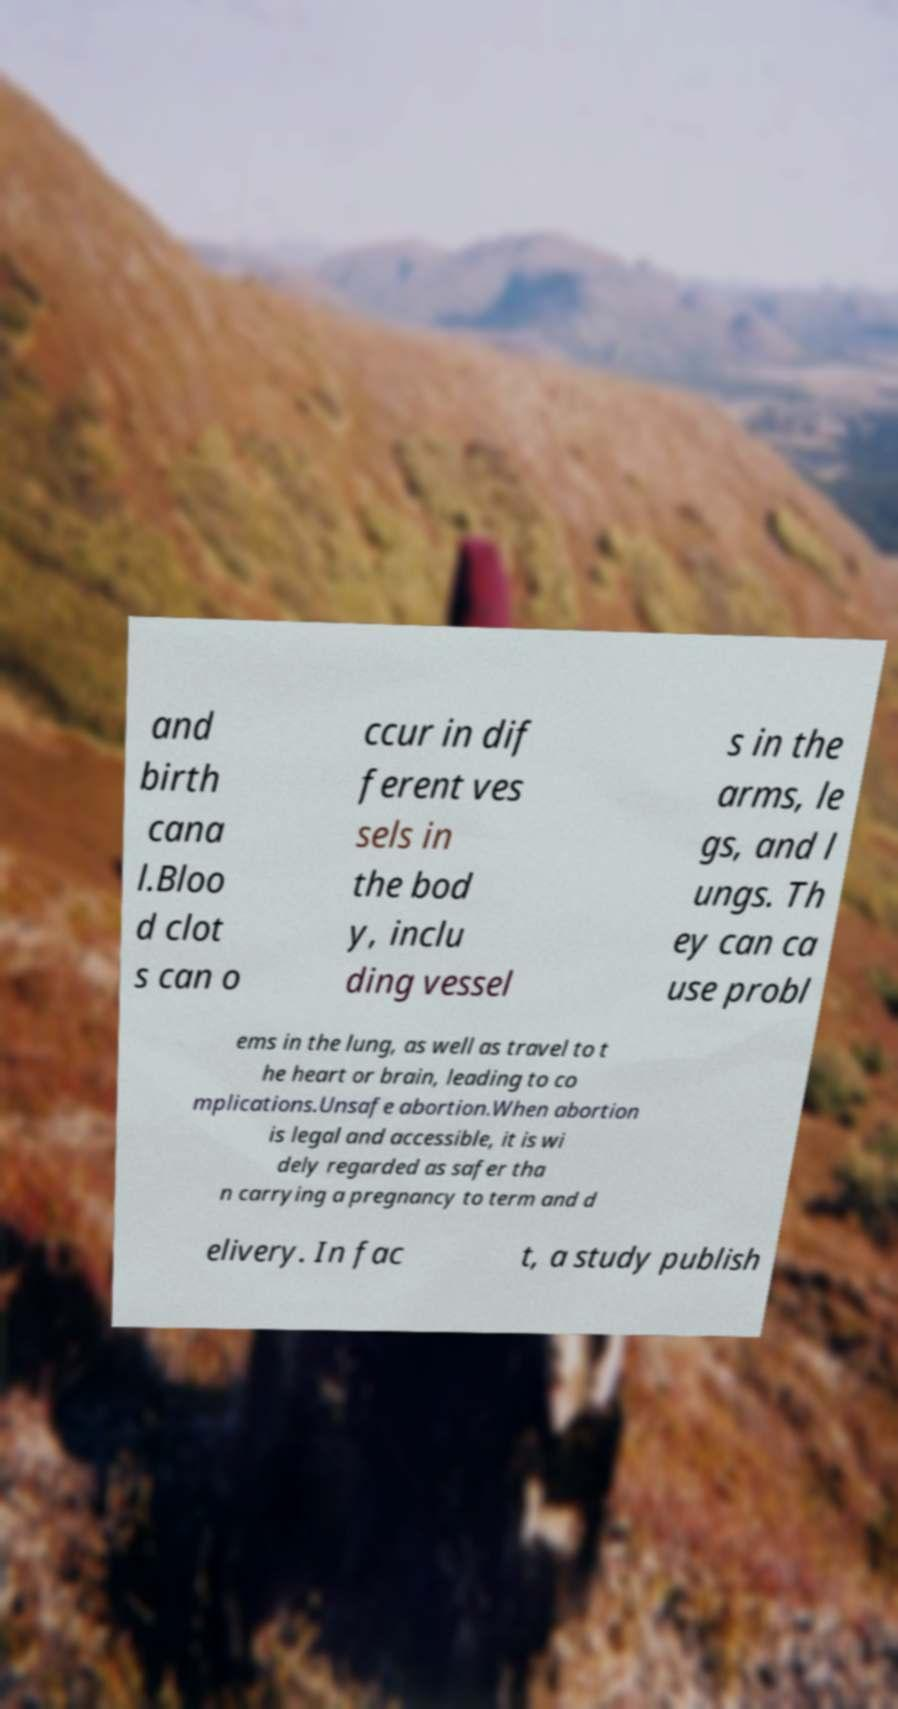Can you read and provide the text displayed in the image?This photo seems to have some interesting text. Can you extract and type it out for me? and birth cana l.Bloo d clot s can o ccur in dif ferent ves sels in the bod y, inclu ding vessel s in the arms, le gs, and l ungs. Th ey can ca use probl ems in the lung, as well as travel to t he heart or brain, leading to co mplications.Unsafe abortion.When abortion is legal and accessible, it is wi dely regarded as safer tha n carrying a pregnancy to term and d elivery. In fac t, a study publish 